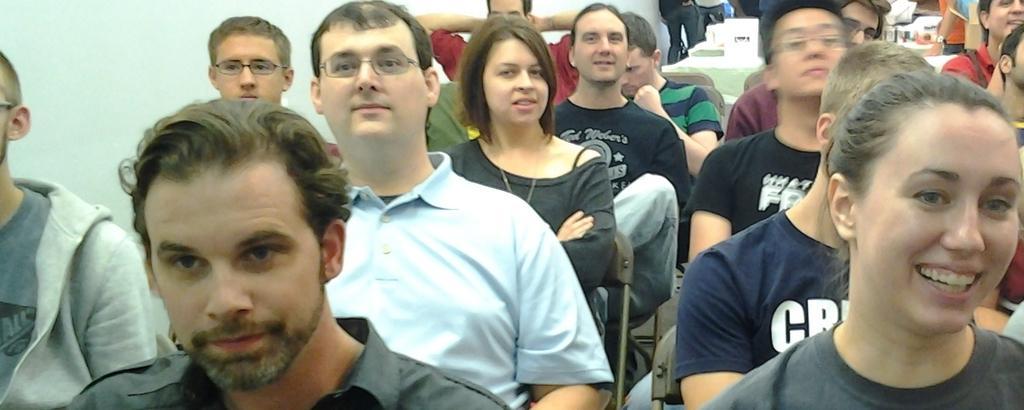Could you give a brief overview of what you see in this image? In this image, we can see persons wearing clothes. There are some persons sitting on chairs. There is a wall in the top left of the image. 